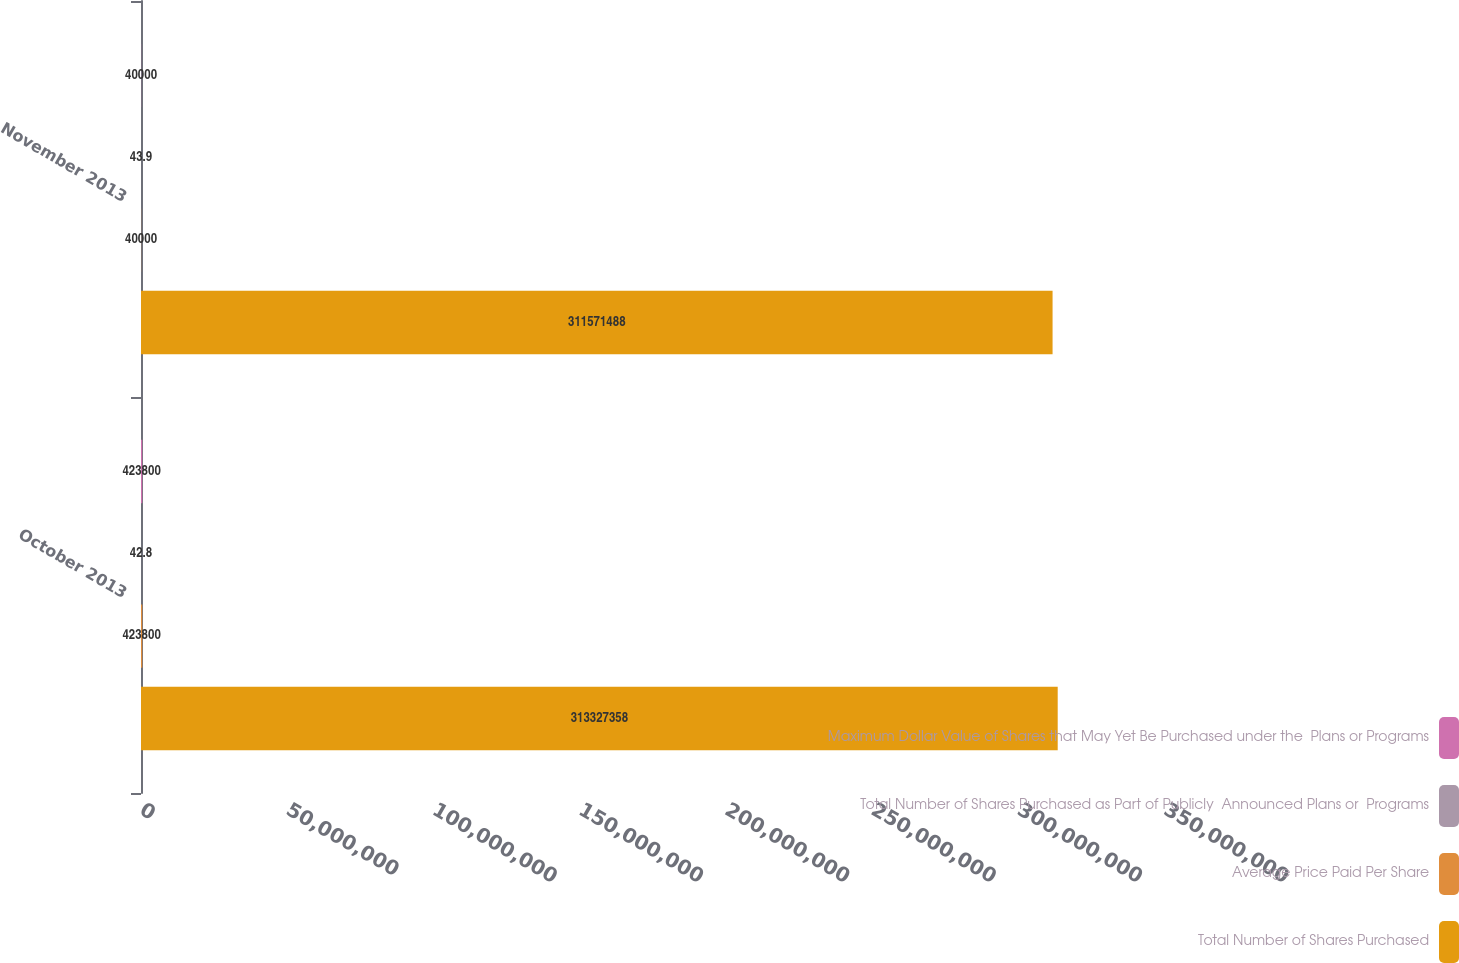<chart> <loc_0><loc_0><loc_500><loc_500><stacked_bar_chart><ecel><fcel>October 2013<fcel>November 2013<nl><fcel>Maximum Dollar Value of Shares that May Yet Be Purchased under the  Plans or Programs<fcel>423800<fcel>40000<nl><fcel>Total Number of Shares Purchased as Part of Publicly  Announced Plans or  Programs<fcel>42.8<fcel>43.9<nl><fcel>Average Price Paid Per Share<fcel>423800<fcel>40000<nl><fcel>Total Number of Shares Purchased<fcel>3.13327e+08<fcel>3.11571e+08<nl></chart> 